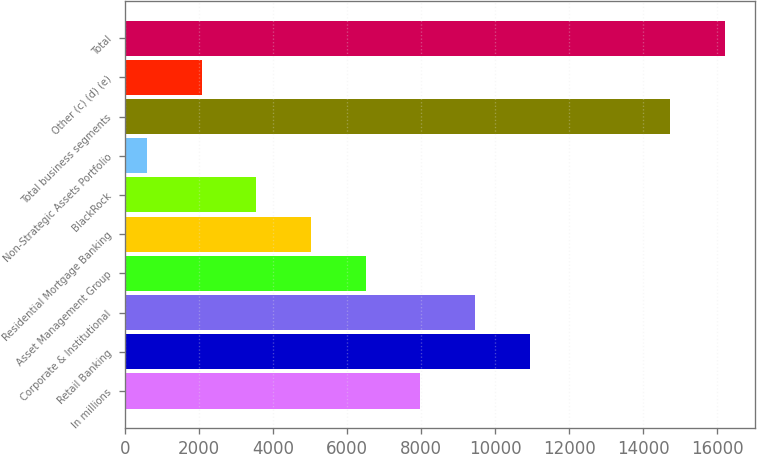Convert chart. <chart><loc_0><loc_0><loc_500><loc_500><bar_chart><fcel>In millions<fcel>Retail Banking<fcel>Corporate & Institutional<fcel>Asset Management Group<fcel>Residential Mortgage Banking<fcel>BlackRock<fcel>Non-Strategic Assets Portfolio<fcel>Total business segments<fcel>Other (c) (d) (e)<fcel>Total<nl><fcel>7981<fcel>10938.6<fcel>9459.8<fcel>6502.2<fcel>5023.4<fcel>3544.6<fcel>587<fcel>14722<fcel>2065.8<fcel>16200.8<nl></chart> 